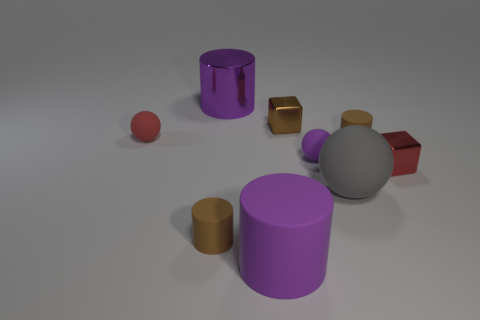There is a big thing that is in front of the red block and on the left side of the tiny purple matte sphere; what is its color?
Make the answer very short. Purple. Do the rubber object on the right side of the big gray object and the brown cylinder on the left side of the purple shiny object have the same size?
Your response must be concise. Yes. How many tiny metallic things are the same color as the metallic cylinder?
Ensure brevity in your answer.  0. What number of big things are red spheres or green matte cylinders?
Your answer should be compact. 0. Is the material of the red object on the right side of the purple shiny thing the same as the small red sphere?
Your response must be concise. No. What is the color of the large matte sphere in front of the metallic cylinder?
Offer a very short reply. Gray. Is there a brown rubber cylinder that has the same size as the purple shiny object?
Keep it short and to the point. No. There is another cube that is the same size as the brown metallic cube; what is its material?
Make the answer very short. Metal. There is a purple metal cylinder; does it have the same size as the brown cylinder in front of the red block?
Offer a terse response. No. There is a small brown cylinder left of the brown shiny cube; what is it made of?
Give a very brief answer. Rubber. 